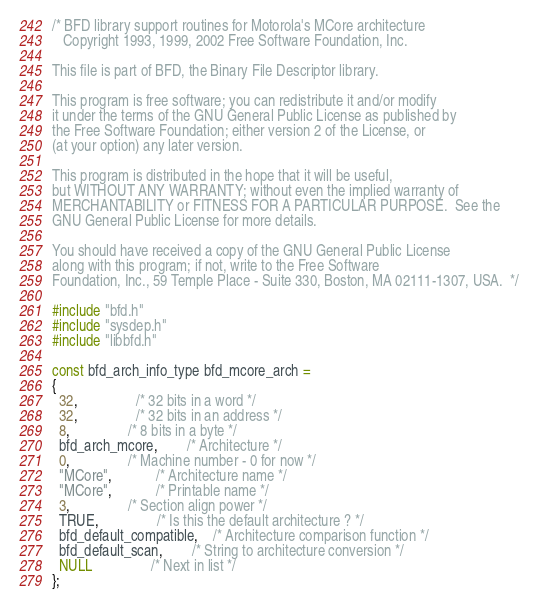Convert code to text. <code><loc_0><loc_0><loc_500><loc_500><_C_>/* BFD library support routines for Motorola's MCore architecture
   Copyright 1993, 1999, 2002 Free Software Foundation, Inc.

This file is part of BFD, the Binary File Descriptor library.

This program is free software; you can redistribute it and/or modify
it under the terms of the GNU General Public License as published by
the Free Software Foundation; either version 2 of the License, or
(at your option) any later version.

This program is distributed in the hope that it will be useful,
but WITHOUT ANY WARRANTY; without even the implied warranty of
MERCHANTABILITY or FITNESS FOR A PARTICULAR PURPOSE.  See the
GNU General Public License for more details.

You should have received a copy of the GNU General Public License
along with this program; if not, write to the Free Software
Foundation, Inc., 59 Temple Place - Suite 330, Boston, MA 02111-1307, USA.  */

#include "bfd.h"
#include "sysdep.h"
#include "libbfd.h"

const bfd_arch_info_type bfd_mcore_arch =
{
  32,		  		/* 32 bits in a word */
  32,		  		/* 32 bits in an address */
  8,		  		/* 8 bits in a byte */
  bfd_arch_mcore, 		/* Architecture */
  0,		  		/* Machine number - 0 for now */
  "MCore",	  		/* Architecture name */
  "MCore",	  		/* Printable name */
  3,		  		/* Section align power */
  TRUE,		  		/* Is this the default architecture ? */
  bfd_default_compatible,	/* Architecture comparison function */
  bfd_default_scan,	   	/* String to architecture conversion */
  NULL			   	/* Next in list */
};
</code> 